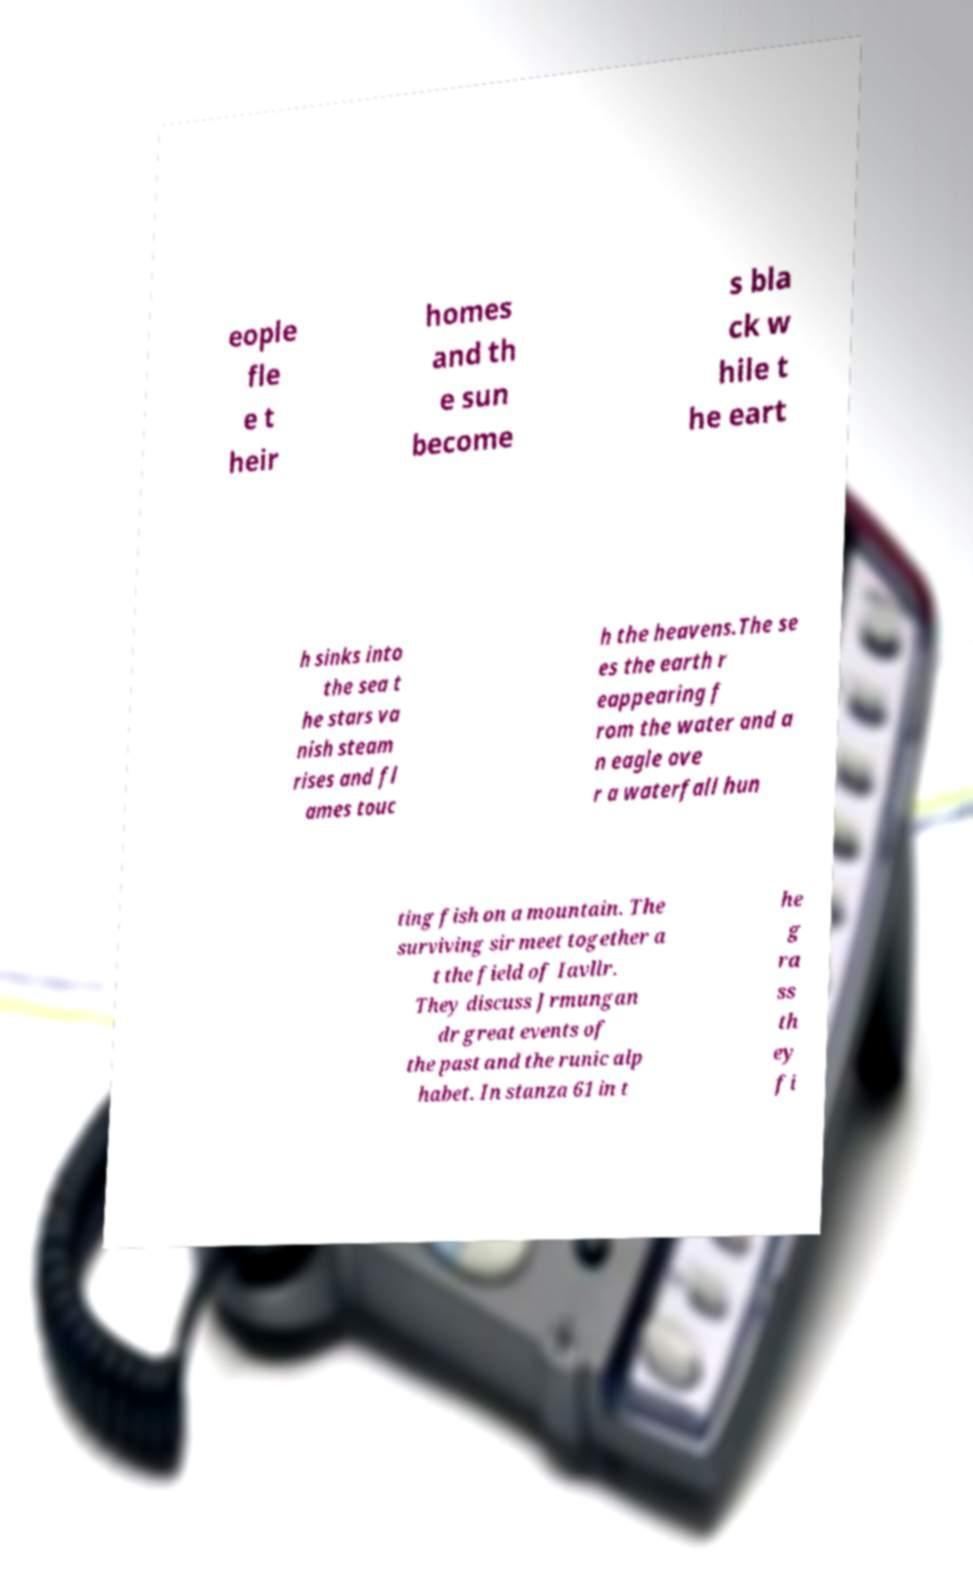Can you accurately transcribe the text from the provided image for me? eople fle e t heir homes and th e sun become s bla ck w hile t he eart h sinks into the sea t he stars va nish steam rises and fl ames touc h the heavens.The se es the earth r eappearing f rom the water and a n eagle ove r a waterfall hun ting fish on a mountain. The surviving sir meet together a t the field of Iavllr. They discuss Jrmungan dr great events of the past and the runic alp habet. In stanza 61 in t he g ra ss th ey fi 